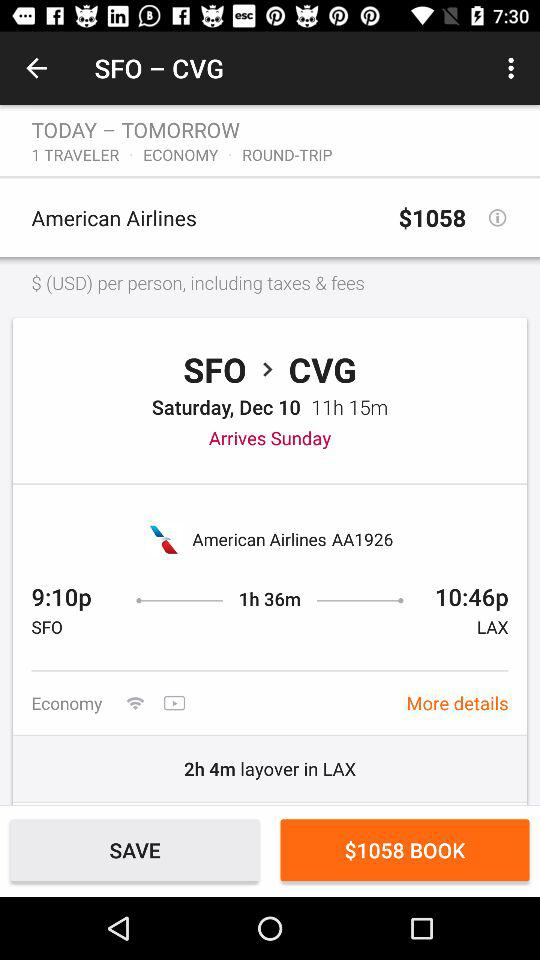How much time does it take to reach LAX from SFO? It takes 1 hour 36 minutes to reach LAX from SFO. 